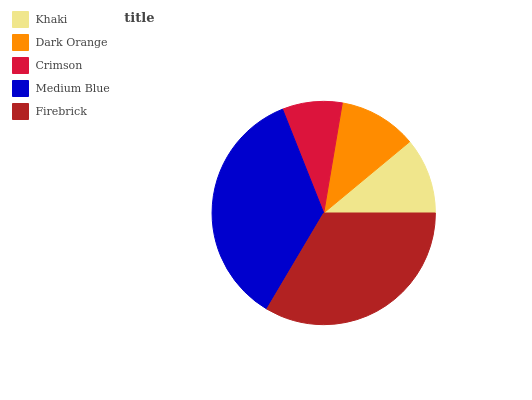Is Crimson the minimum?
Answer yes or no. Yes. Is Medium Blue the maximum?
Answer yes or no. Yes. Is Dark Orange the minimum?
Answer yes or no. No. Is Dark Orange the maximum?
Answer yes or no. No. Is Dark Orange greater than Khaki?
Answer yes or no. Yes. Is Khaki less than Dark Orange?
Answer yes or no. Yes. Is Khaki greater than Dark Orange?
Answer yes or no. No. Is Dark Orange less than Khaki?
Answer yes or no. No. Is Dark Orange the high median?
Answer yes or no. Yes. Is Dark Orange the low median?
Answer yes or no. Yes. Is Crimson the high median?
Answer yes or no. No. Is Crimson the low median?
Answer yes or no. No. 